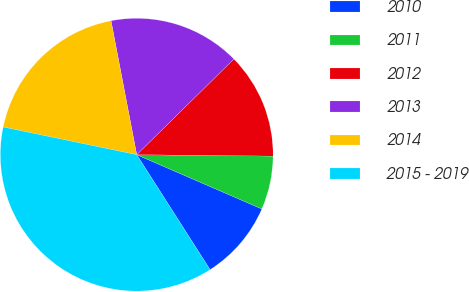<chart> <loc_0><loc_0><loc_500><loc_500><pie_chart><fcel>2010<fcel>2011<fcel>2012<fcel>2013<fcel>2014<fcel>2015 - 2019<nl><fcel>9.45%<fcel>6.35%<fcel>12.54%<fcel>15.64%<fcel>18.73%<fcel>37.3%<nl></chart> 